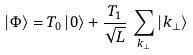Convert formula to latex. <formula><loc_0><loc_0><loc_500><loc_500>| \Phi \rangle = T _ { 0 } \, | 0 \rangle + \frac { T _ { 1 } } { \sqrt { L } } \, \sum _ { k _ { \perp } } | k _ { \perp } \rangle</formula> 